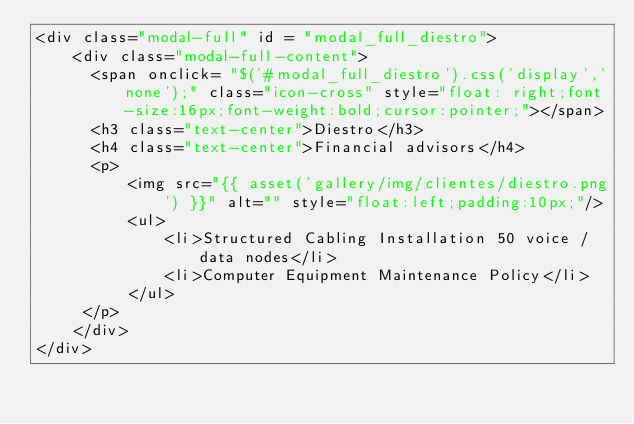<code> <loc_0><loc_0><loc_500><loc_500><_PHP_><div class="modal-full" id = "modal_full_diestro">
    <div class="modal-full-content">
      <span onclick= "$('#modal_full_diestro').css('display','none');" class="icon-cross" style="float: right;font-size:16px;font-weight:bold;cursor:pointer;"></span>
      <h3 class="text-center">Diestro</h3>
      <h4 class="text-center">Financial advisors</h4>
      <p>
          <img src="{{ asset('gallery/img/clientes/diestro.png') }}" alt="" style="float:left;padding:10px;"/>
          <ul>
              <li>Structured Cabling Installation 50 voice / data nodes</li>
              <li>Computer Equipment Maintenance Policy</li>
          </ul>
     </p>
    </div>
</div></code> 